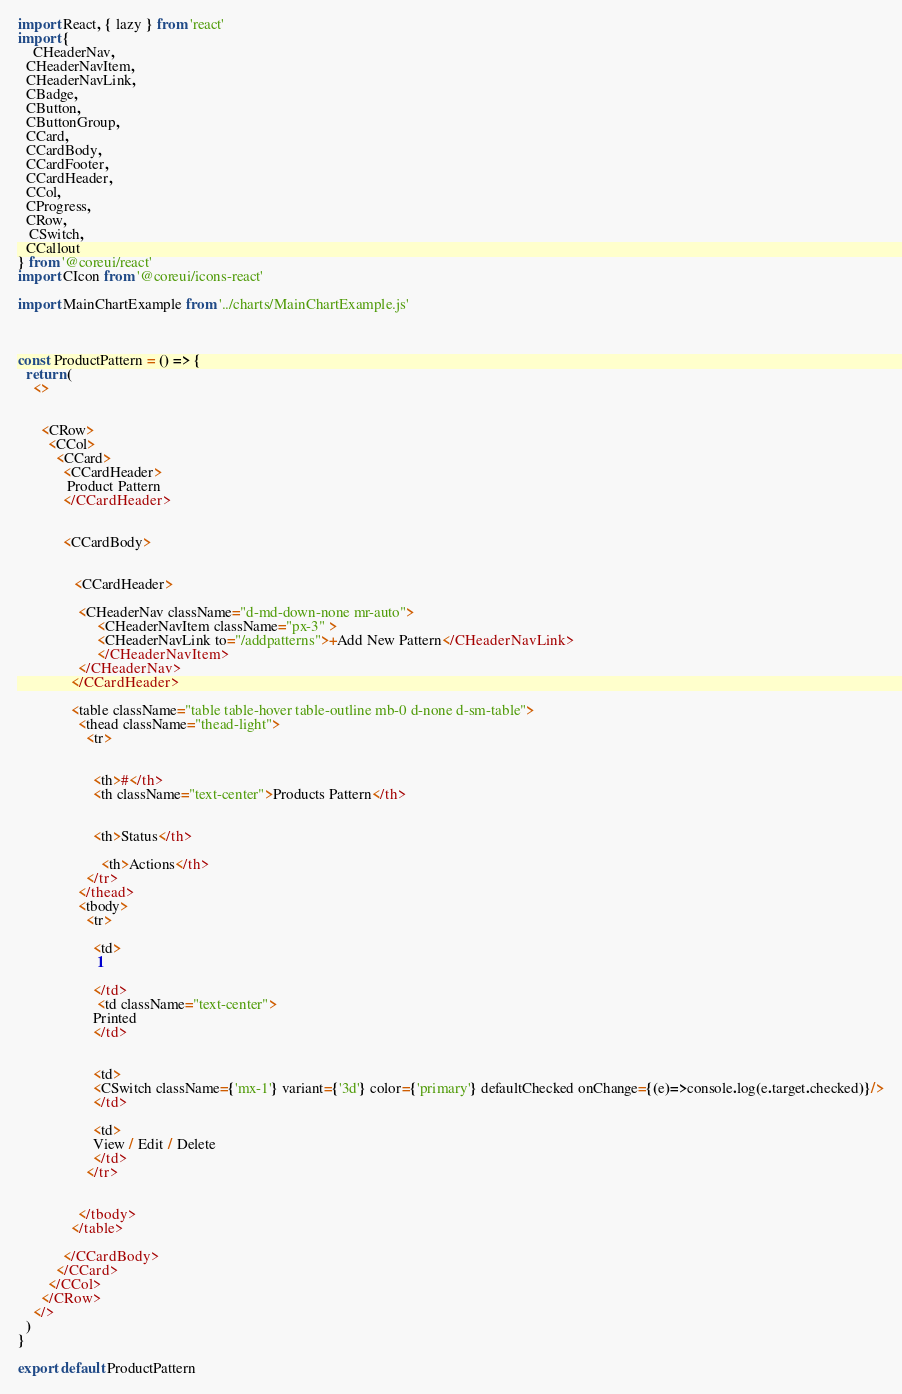<code> <loc_0><loc_0><loc_500><loc_500><_JavaScript_>import React, { lazy } from 'react'
import {
	CHeaderNav,
  CHeaderNavItem,
  CHeaderNavLink,
  CBadge,
  CButton,
  CButtonGroup,
  CCard,
  CCardBody,
  CCardFooter,
  CCardHeader,
  CCol,
  CProgress,
  CRow,
   CSwitch,
  CCallout
} from '@coreui/react'
import CIcon from '@coreui/icons-react'

import MainChartExample from '../charts/MainChartExample.js'



const ProductPattern = () => {
  return (
    <>
      

      <CRow>
        <CCol>
          <CCard>
            <CCardHeader>
             Product Pattern
            </CCardHeader>
			
		   
            <CCardBody>
              

               <CCardHeader>
		  
                <CHeaderNav className="d-md-down-none mr-auto">
                     <CHeaderNavItem className="px-3" >
                     <CHeaderNavLink to="/addpatterns">+Add New Pattern</CHeaderNavLink>
                     </CHeaderNavItem>
                </CHeaderNav>
              </CCardHeader>

              <table className="table table-hover table-outline mb-0 d-none d-sm-table">
                <thead className="thead-light">
                  <tr>
                    
                   
                    <th>#</th>
                    <th className="text-center">Products Pattern</th>
					
					
					<th>Status</th>
					
					  <th>Actions</th>
                  </tr>
                </thead>
                <tbody>
                  <tr>
                    
                    <td>
                     1
                     
                    </td>
					 <td className="text-center">
                    Printed
                    </td>
                   
                     
					<td>
					<CSwitch className={'mx-1'} variant={'3d'} color={'primary'} defaultChecked onChange={(e)=>console.log(e.target.checked)}/>
					</td>
					
					<td>
					View / Edit / Delete
					</td>
                  </tr>
				   
				  
                </tbody>
              </table>

            </CCardBody>
          </CCard>
        </CCol>
      </CRow>
    </>
  )
}

export default ProductPattern
</code> 